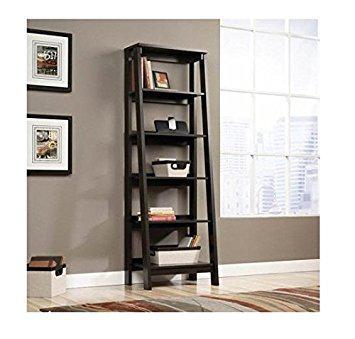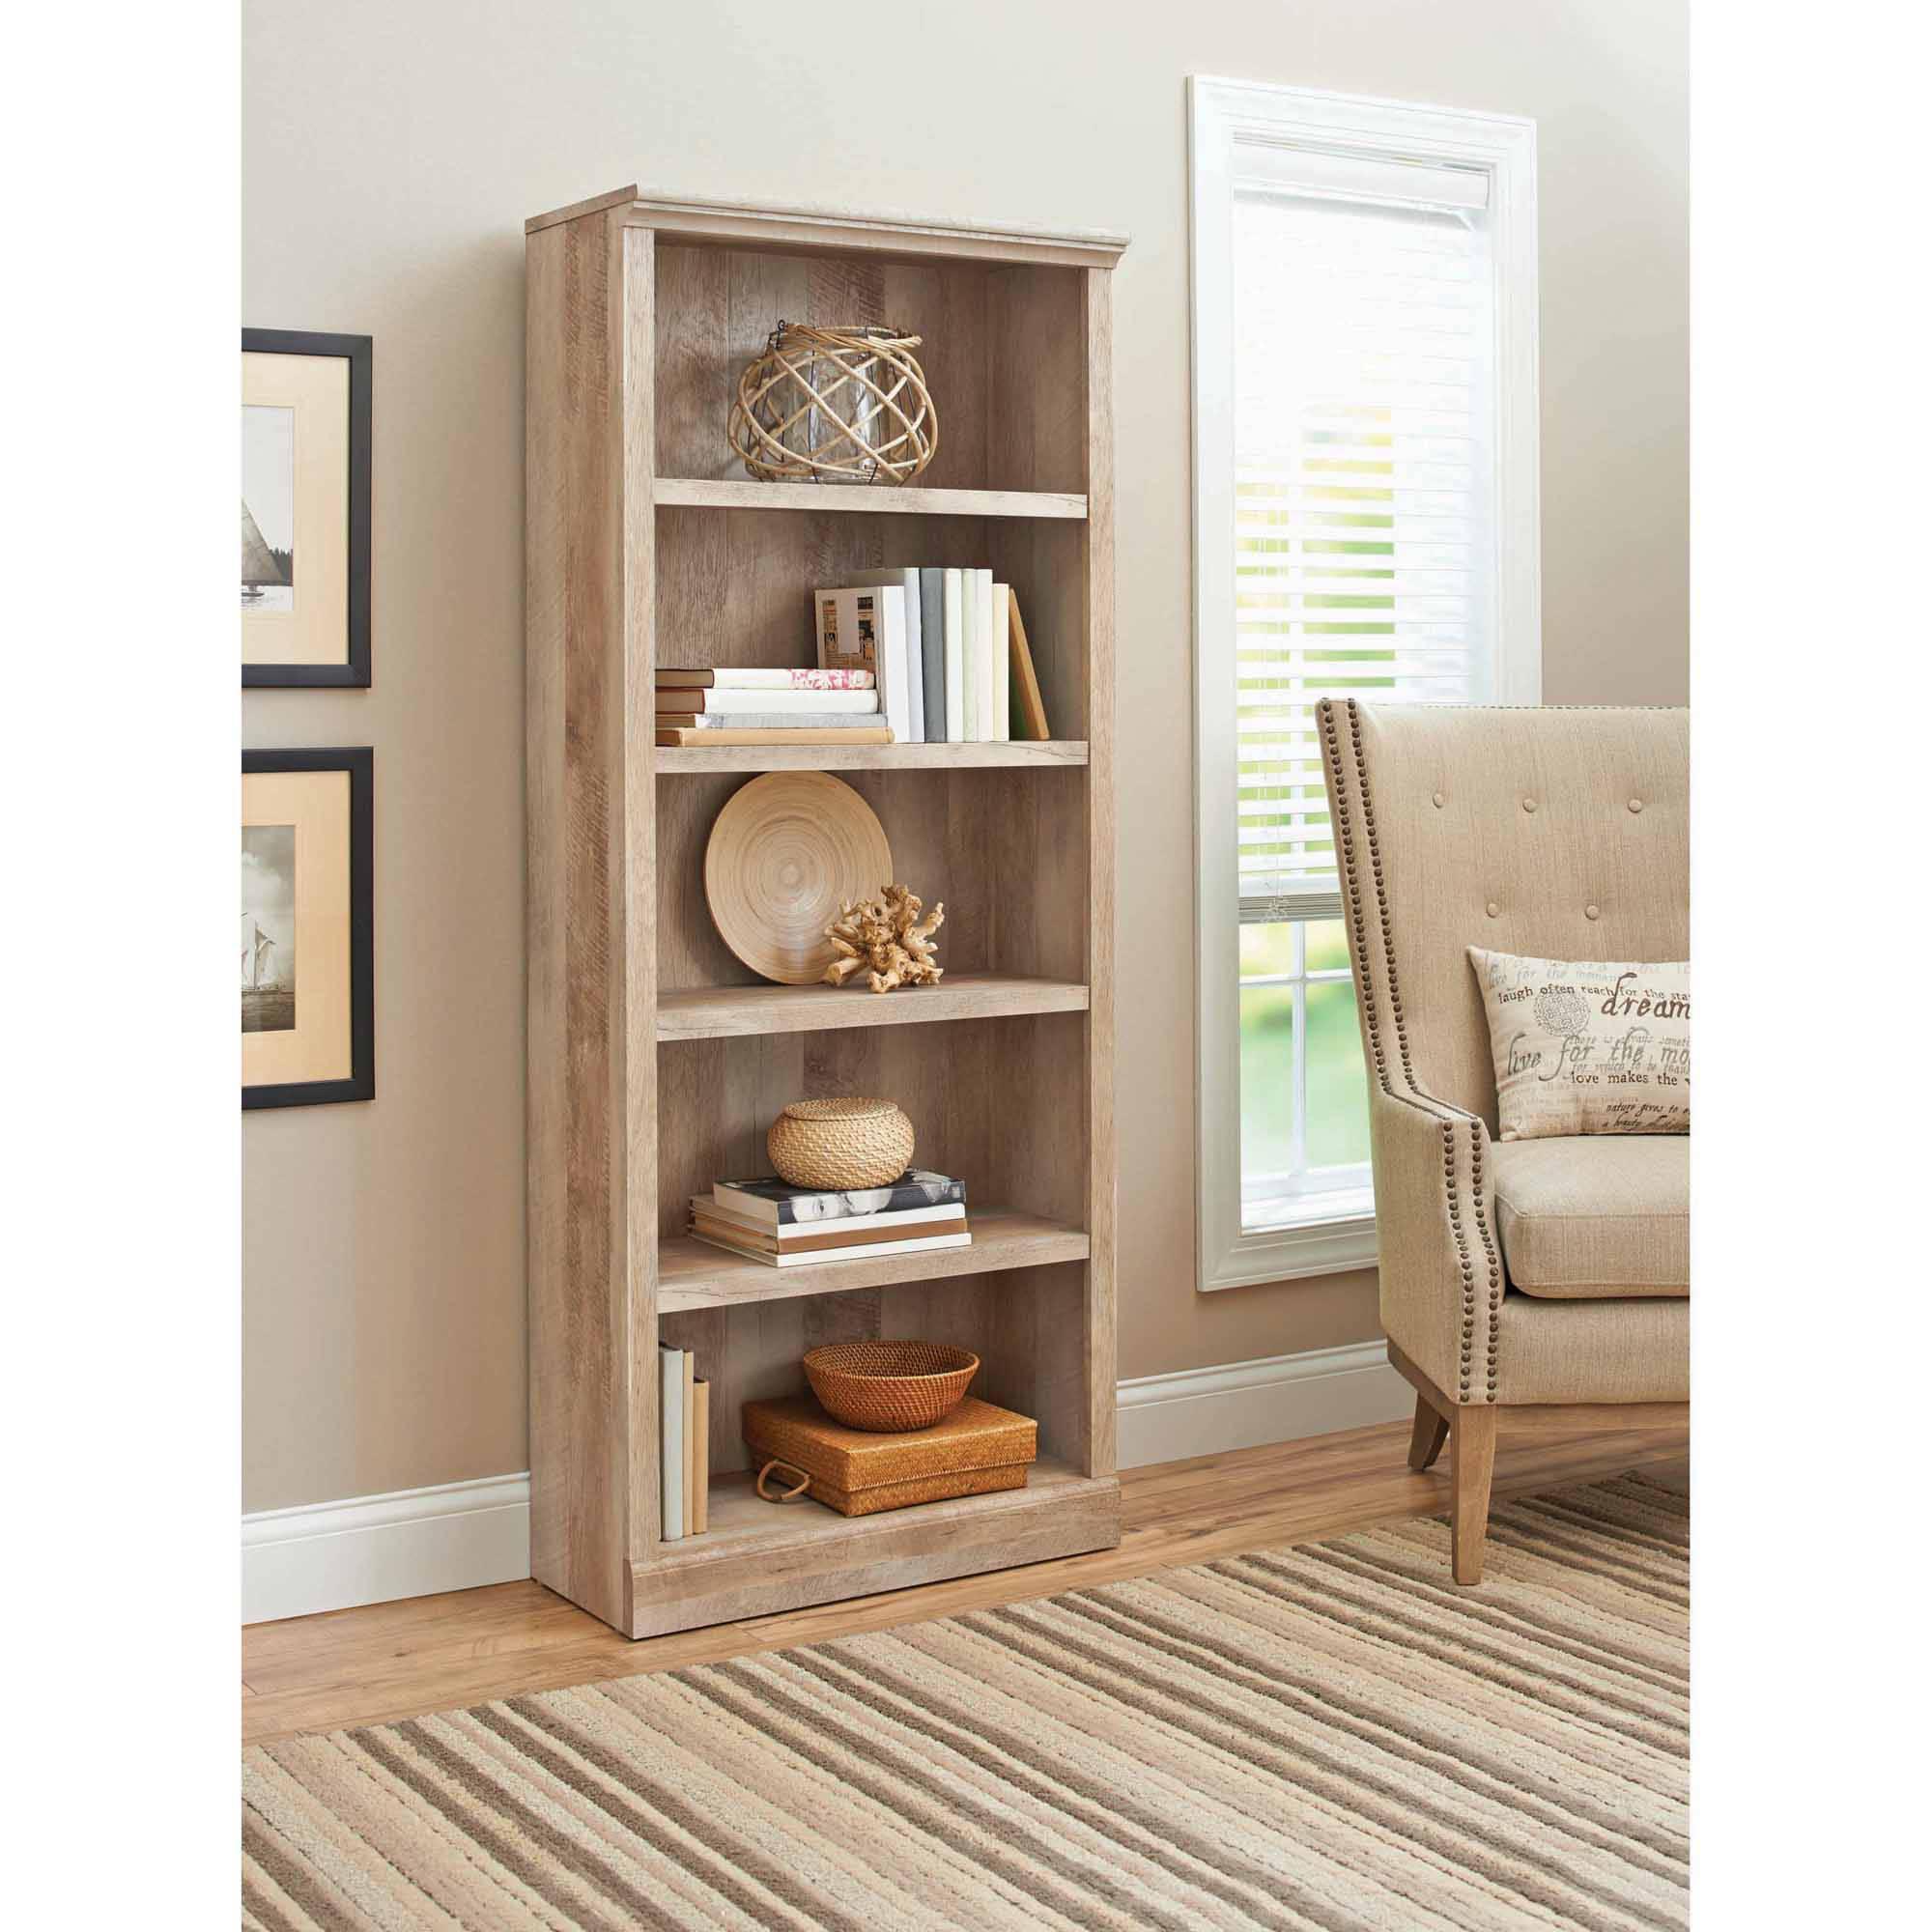The first image is the image on the left, the second image is the image on the right. Examine the images to the left and right. Is the description "At least one shelf has items on it." accurate? Answer yes or no. Yes. The first image is the image on the left, the second image is the image on the right. For the images shown, is this caption "At least one of the bookshelves has four legs in the shape of an inverted v." true? Answer yes or no. Yes. 